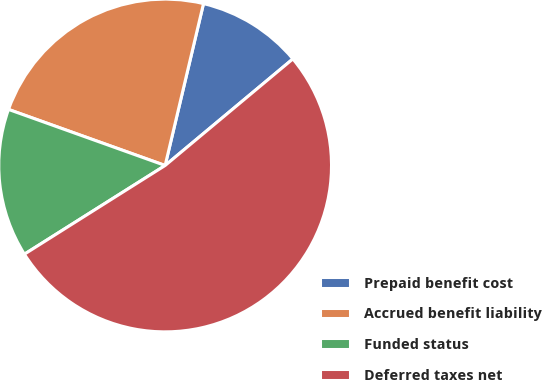<chart> <loc_0><loc_0><loc_500><loc_500><pie_chart><fcel>Prepaid benefit cost<fcel>Accrued benefit liability<fcel>Funded status<fcel>Deferred taxes net<nl><fcel>10.23%<fcel>23.23%<fcel>14.42%<fcel>52.11%<nl></chart> 